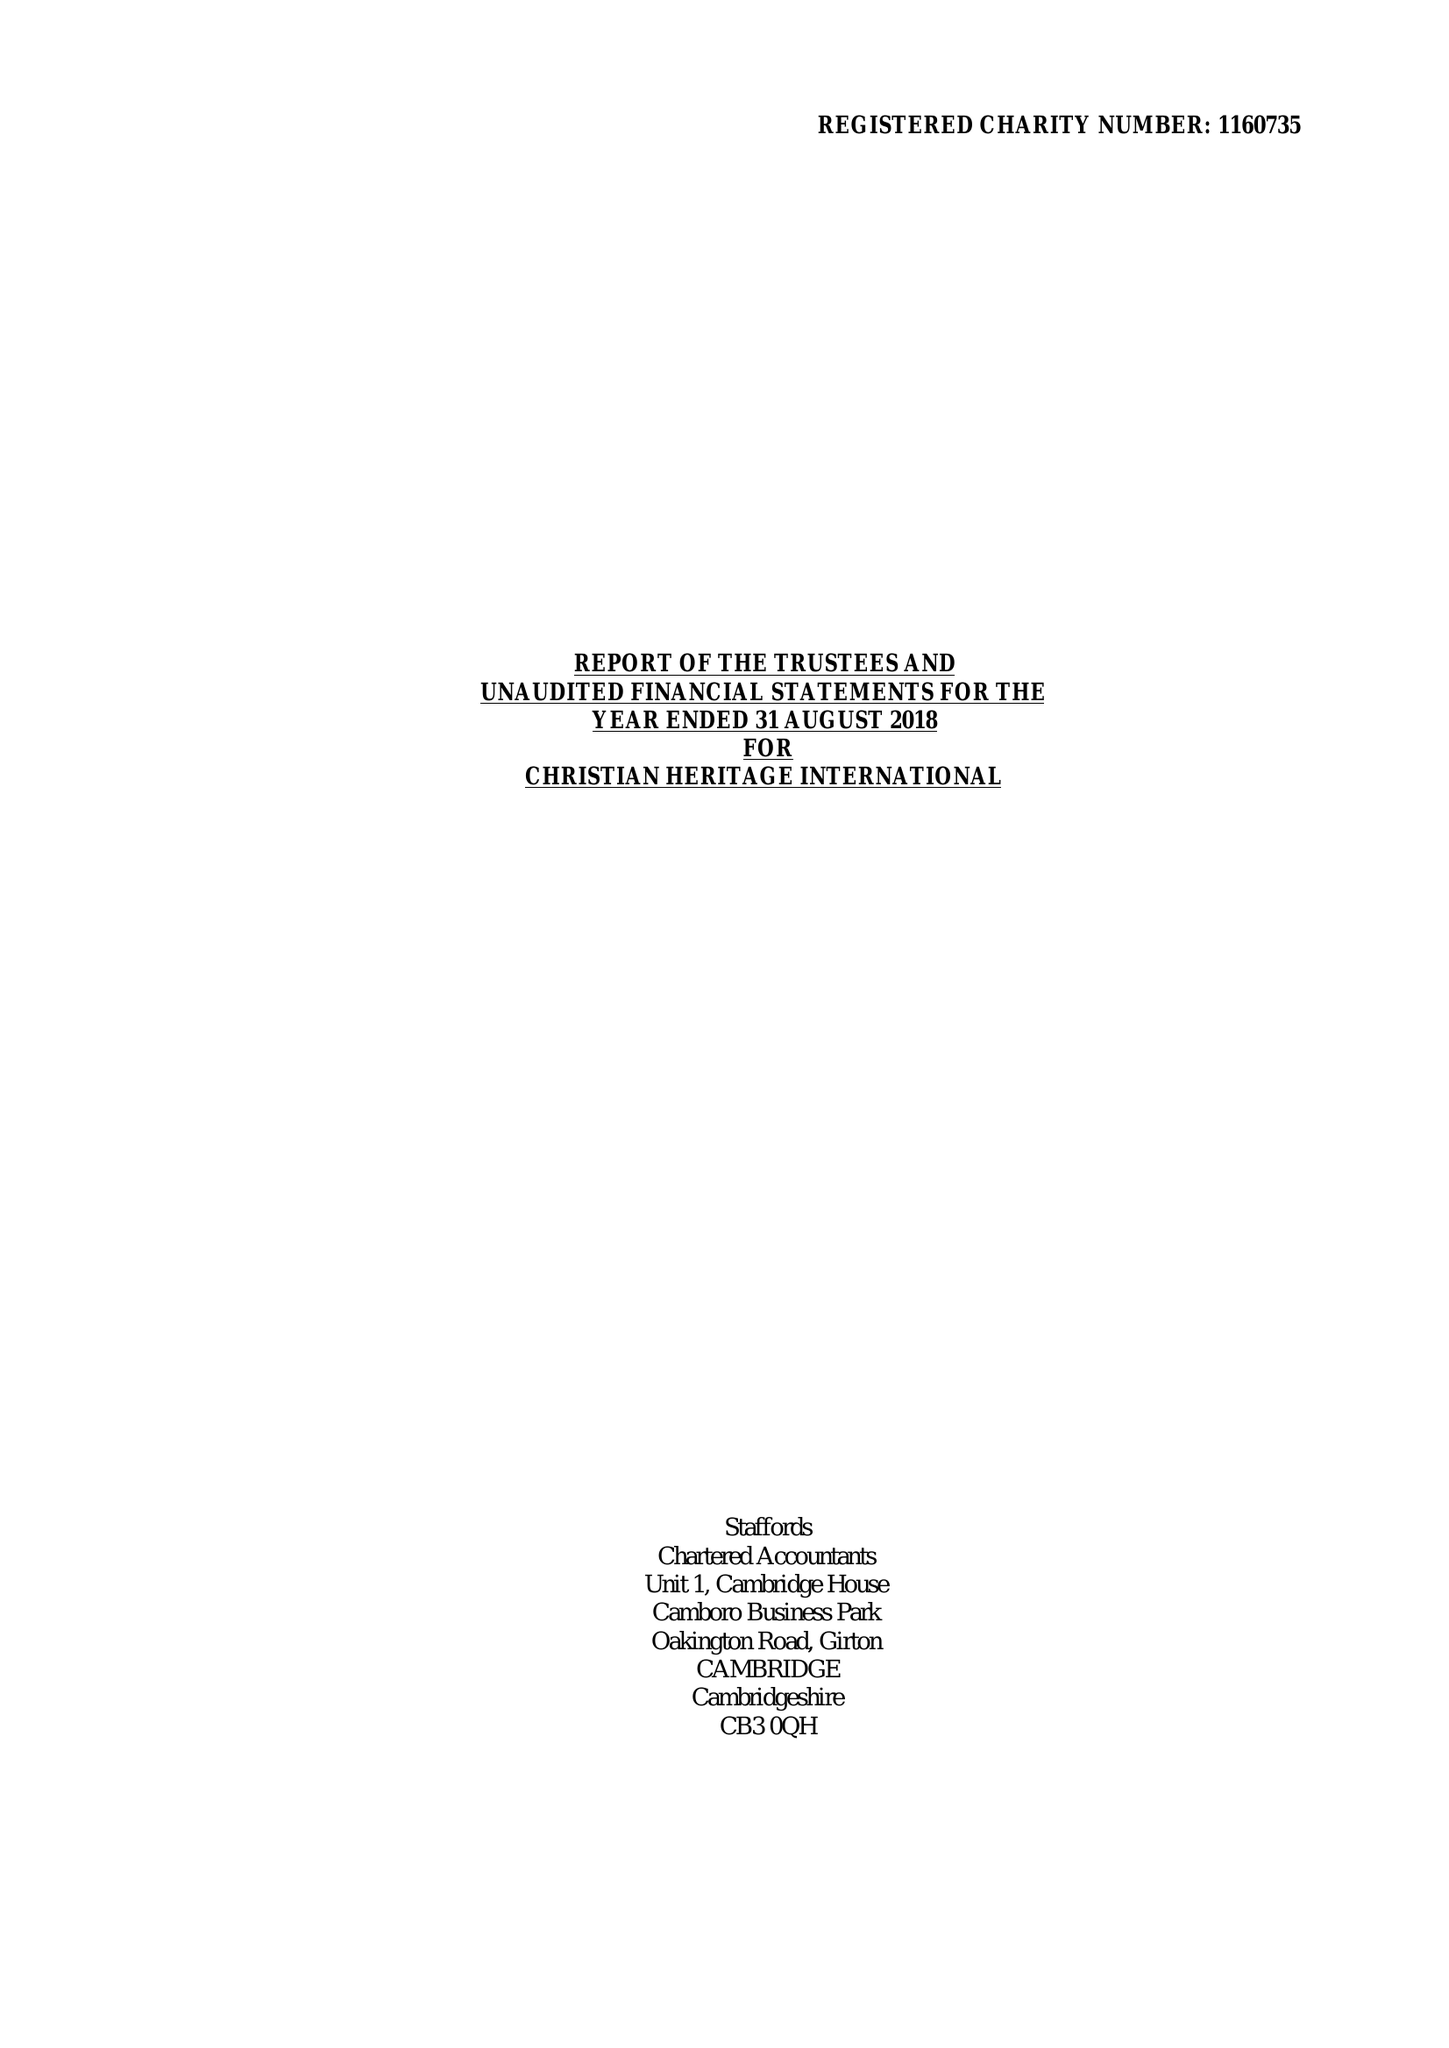What is the value for the report_date?
Answer the question using a single word or phrase. 2018-08-31 